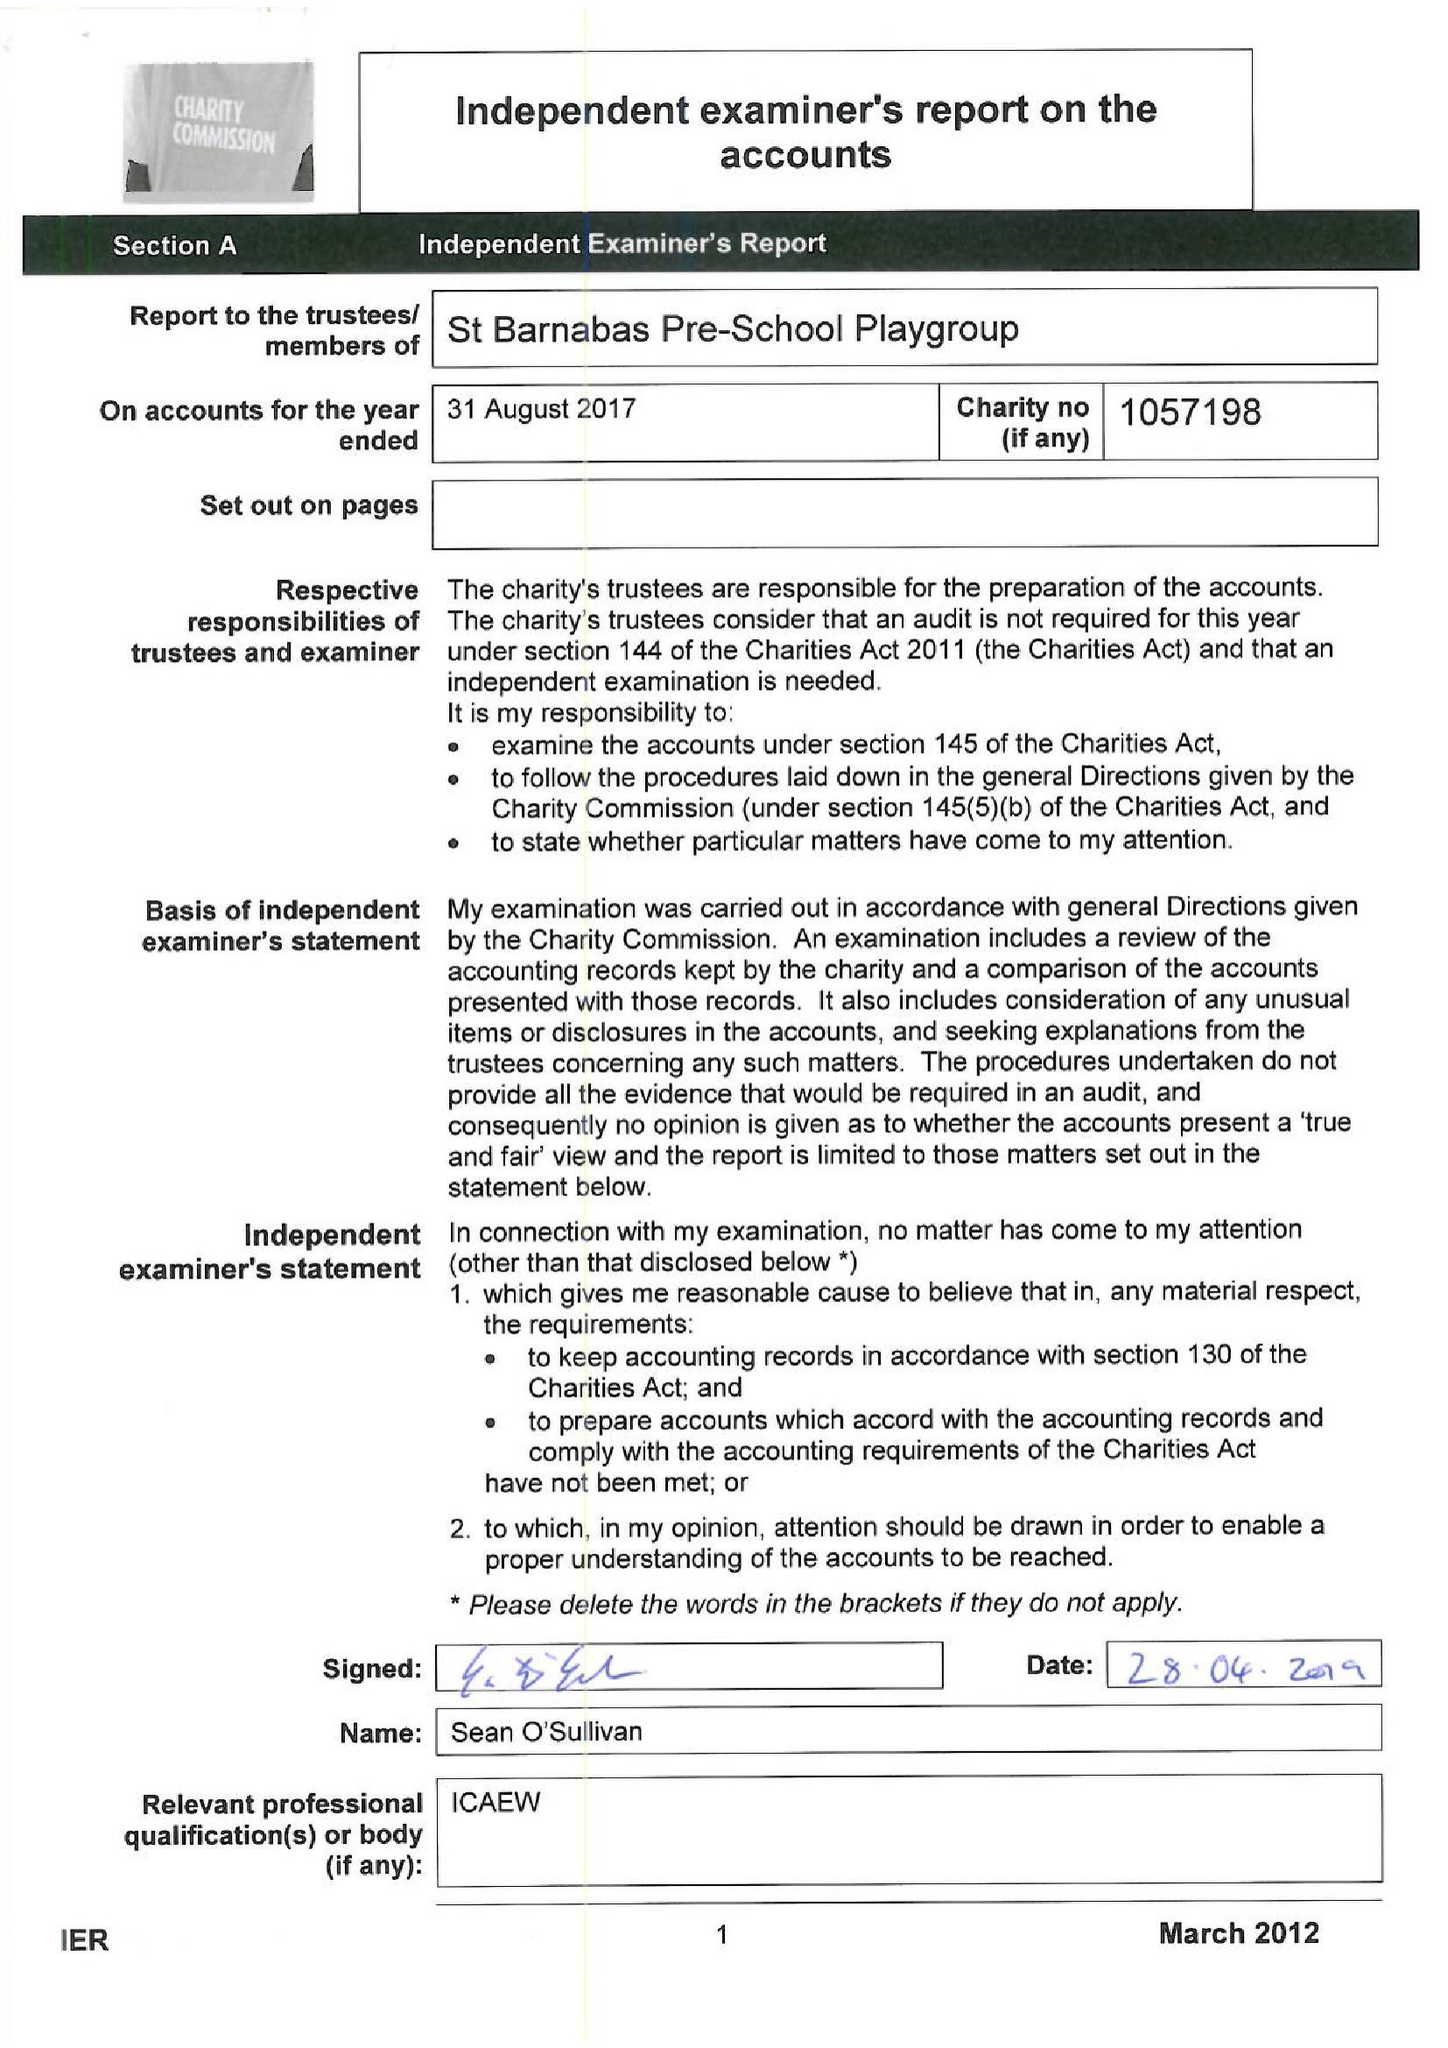What is the value for the address__postcode?
Answer the question using a single word or phrase. W5 1QG 